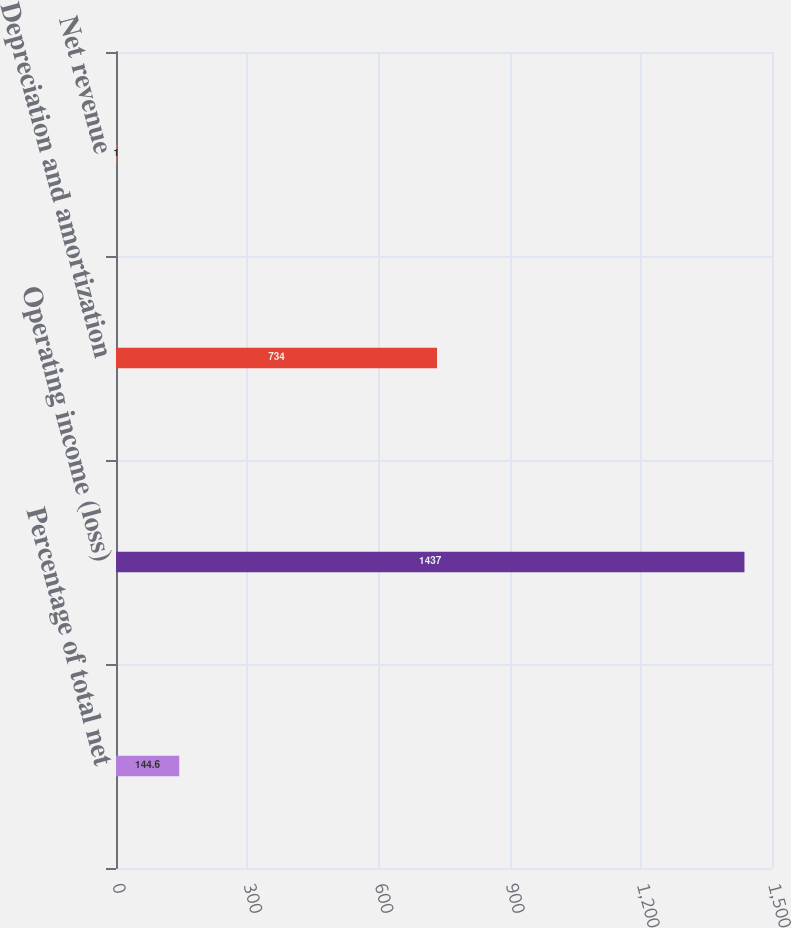Convert chart. <chart><loc_0><loc_0><loc_500><loc_500><bar_chart><fcel>Percentage of total net<fcel>Operating income (loss)<fcel>Depreciation and amortization<fcel>Net revenue<nl><fcel>144.6<fcel>1437<fcel>734<fcel>1<nl></chart> 